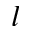Convert formula to latex. <formula><loc_0><loc_0><loc_500><loc_500>l</formula> 